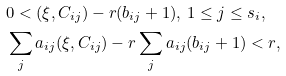Convert formula to latex. <formula><loc_0><loc_0><loc_500><loc_500>& 0 < ( \xi , C _ { i j } ) - r ( b _ { i j } + 1 ) , \, 1 \leq j \leq s _ { i } , \\ & \sum _ { j } a _ { i j } ( \xi , C _ { i j } ) - r \sum _ { j } a _ { i j } ( b _ { i j } + 1 ) < r ,</formula> 